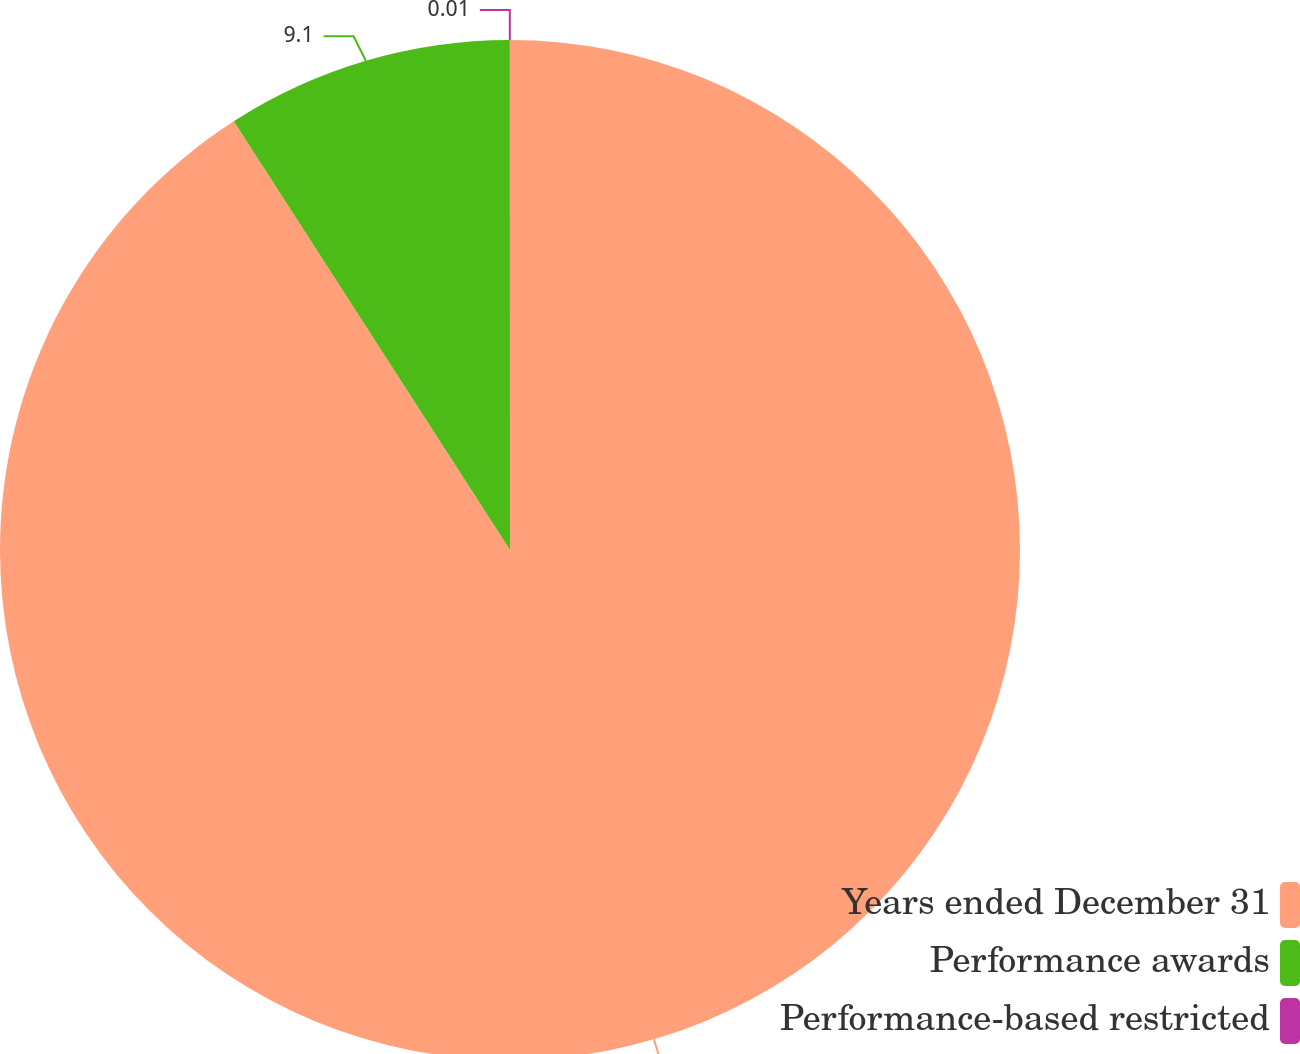Convert chart to OTSL. <chart><loc_0><loc_0><loc_500><loc_500><pie_chart><fcel>Years ended December 31<fcel>Performance awards<fcel>Performance-based restricted<nl><fcel>90.89%<fcel>9.1%<fcel>0.01%<nl></chart> 